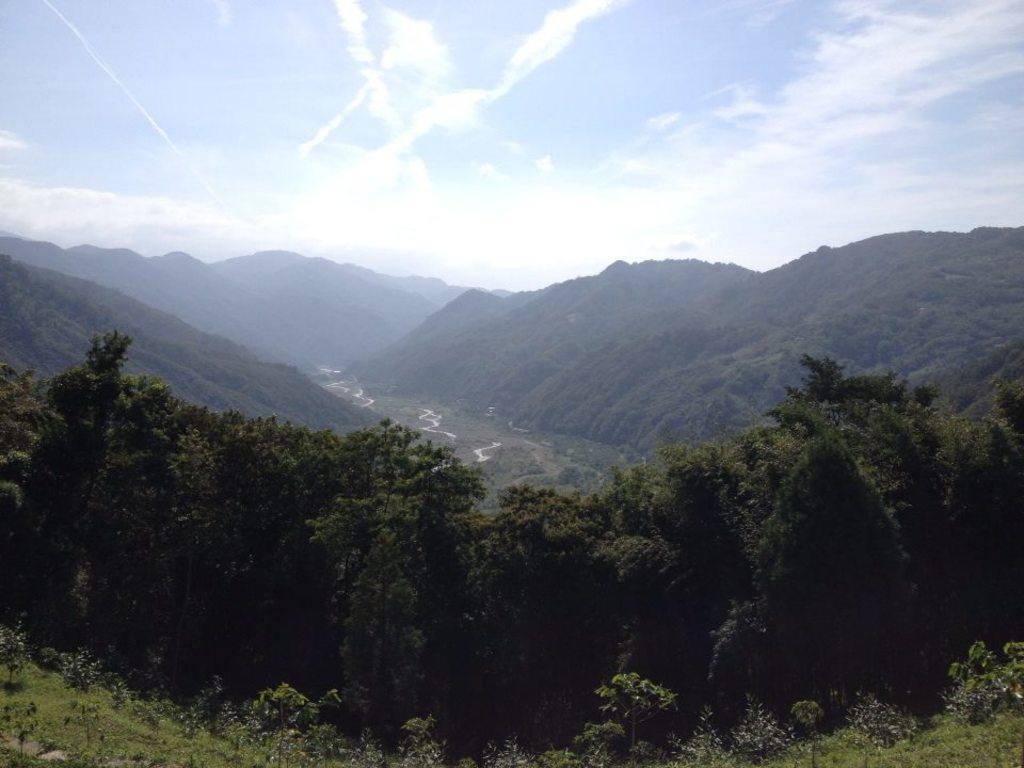In one or two sentences, can you explain what this image depicts? At the bottom of the picture, there are trees and we even see grass. There are hills in the background and at the top of the picture, we see the sky. 